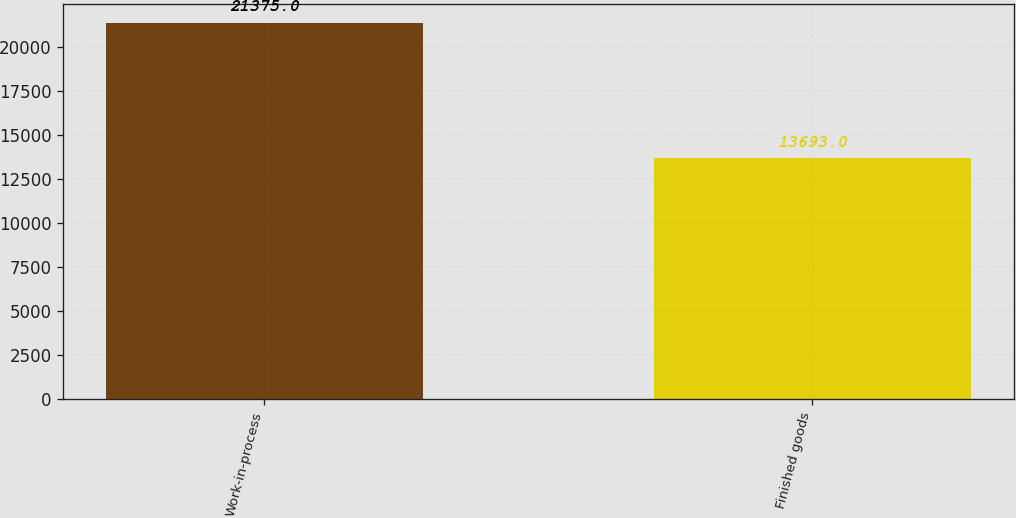Convert chart to OTSL. <chart><loc_0><loc_0><loc_500><loc_500><bar_chart><fcel>Work-in-process<fcel>Finished goods<nl><fcel>21375<fcel>13693<nl></chart> 